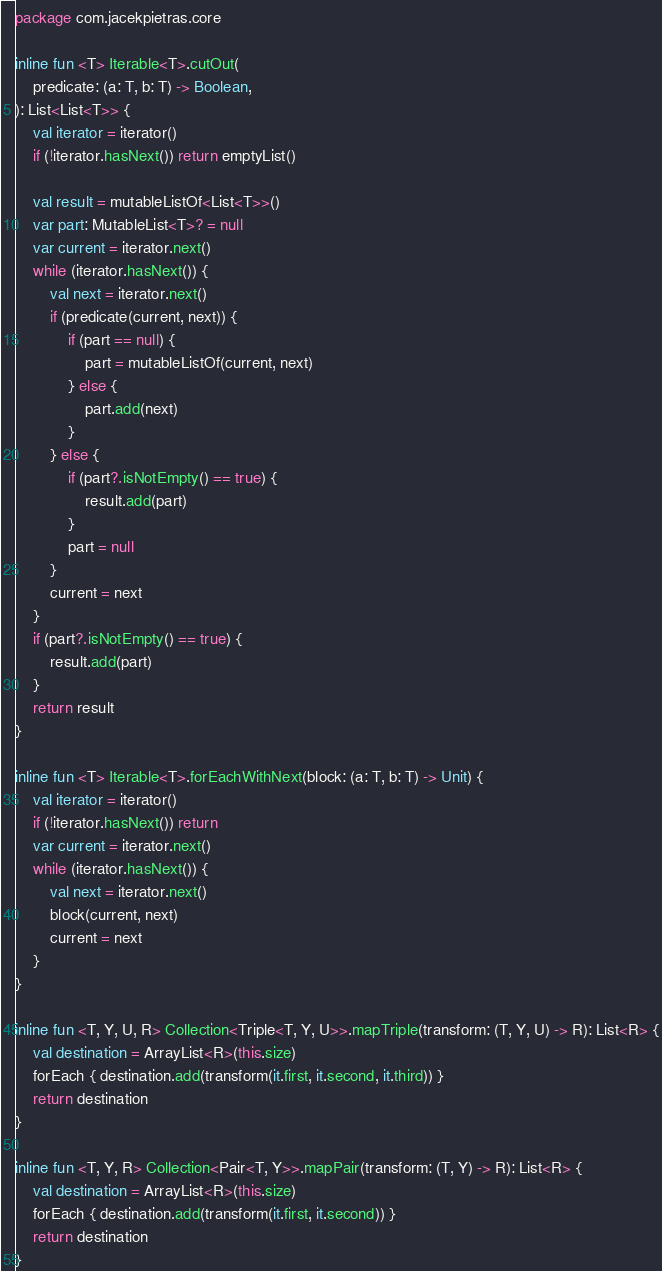Convert code to text. <code><loc_0><loc_0><loc_500><loc_500><_Kotlin_>package com.jacekpietras.core

inline fun <T> Iterable<T>.cutOut(
    predicate: (a: T, b: T) -> Boolean,
): List<List<T>> {
    val iterator = iterator()
    if (!iterator.hasNext()) return emptyList()

    val result = mutableListOf<List<T>>()
    var part: MutableList<T>? = null
    var current = iterator.next()
    while (iterator.hasNext()) {
        val next = iterator.next()
        if (predicate(current, next)) {
            if (part == null) {
                part = mutableListOf(current, next)
            } else {
                part.add(next)
            }
        } else {
            if (part?.isNotEmpty() == true) {
                result.add(part)
            }
            part = null
        }
        current = next
    }
    if (part?.isNotEmpty() == true) {
        result.add(part)
    }
    return result
}

inline fun <T> Iterable<T>.forEachWithNext(block: (a: T, b: T) -> Unit) {
    val iterator = iterator()
    if (!iterator.hasNext()) return
    var current = iterator.next()
    while (iterator.hasNext()) {
        val next = iterator.next()
        block(current, next)
        current = next
    }
}

inline fun <T, Y, U, R> Collection<Triple<T, Y, U>>.mapTriple(transform: (T, Y, U) -> R): List<R> {
    val destination = ArrayList<R>(this.size)
    forEach { destination.add(transform(it.first, it.second, it.third)) }
    return destination
}

inline fun <T, Y, R> Collection<Pair<T, Y>>.mapPair(transform: (T, Y) -> R): List<R> {
    val destination = ArrayList<R>(this.size)
    forEach { destination.add(transform(it.first, it.second)) }
    return destination
}
</code> 